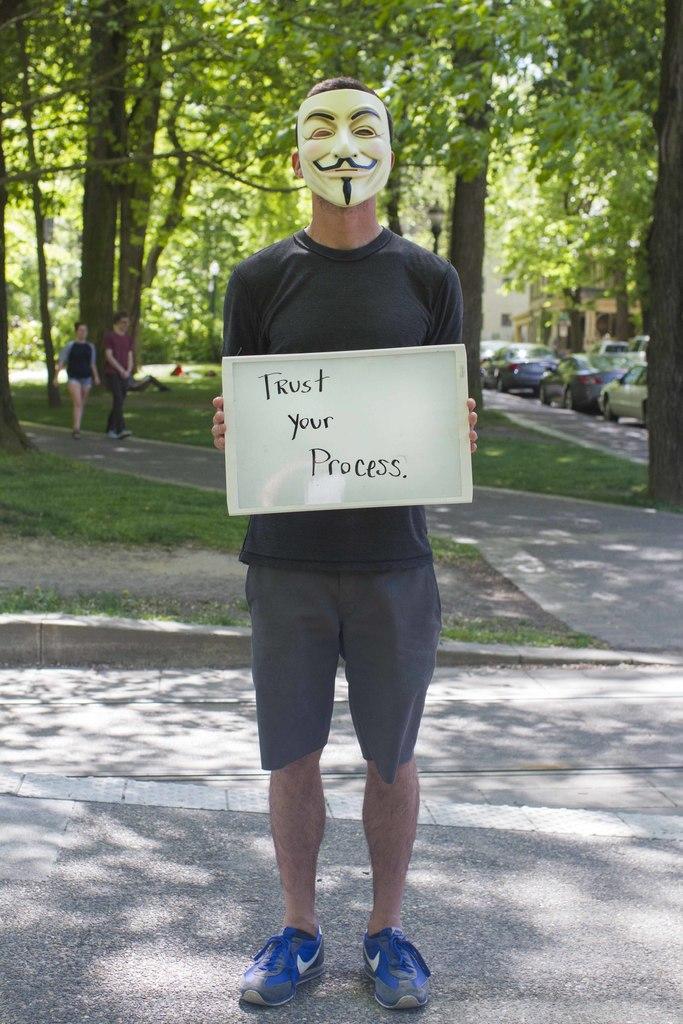Could you give a brief overview of what you see in this image? As we can see in the image there are few people, cars, trees and buildings. There is grass. The man standing in the front is wearing black color t shirt and holding sheet. On sheet it was written as ´trust your process´. 